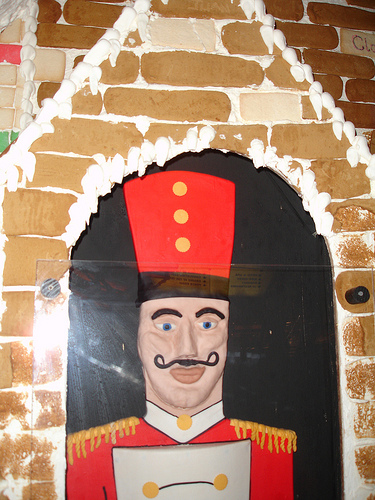<image>
Is the mustache on the gingerbread house? No. The mustache is not positioned on the gingerbread house. They may be near each other, but the mustache is not supported by or resting on top of the gingerbread house. 